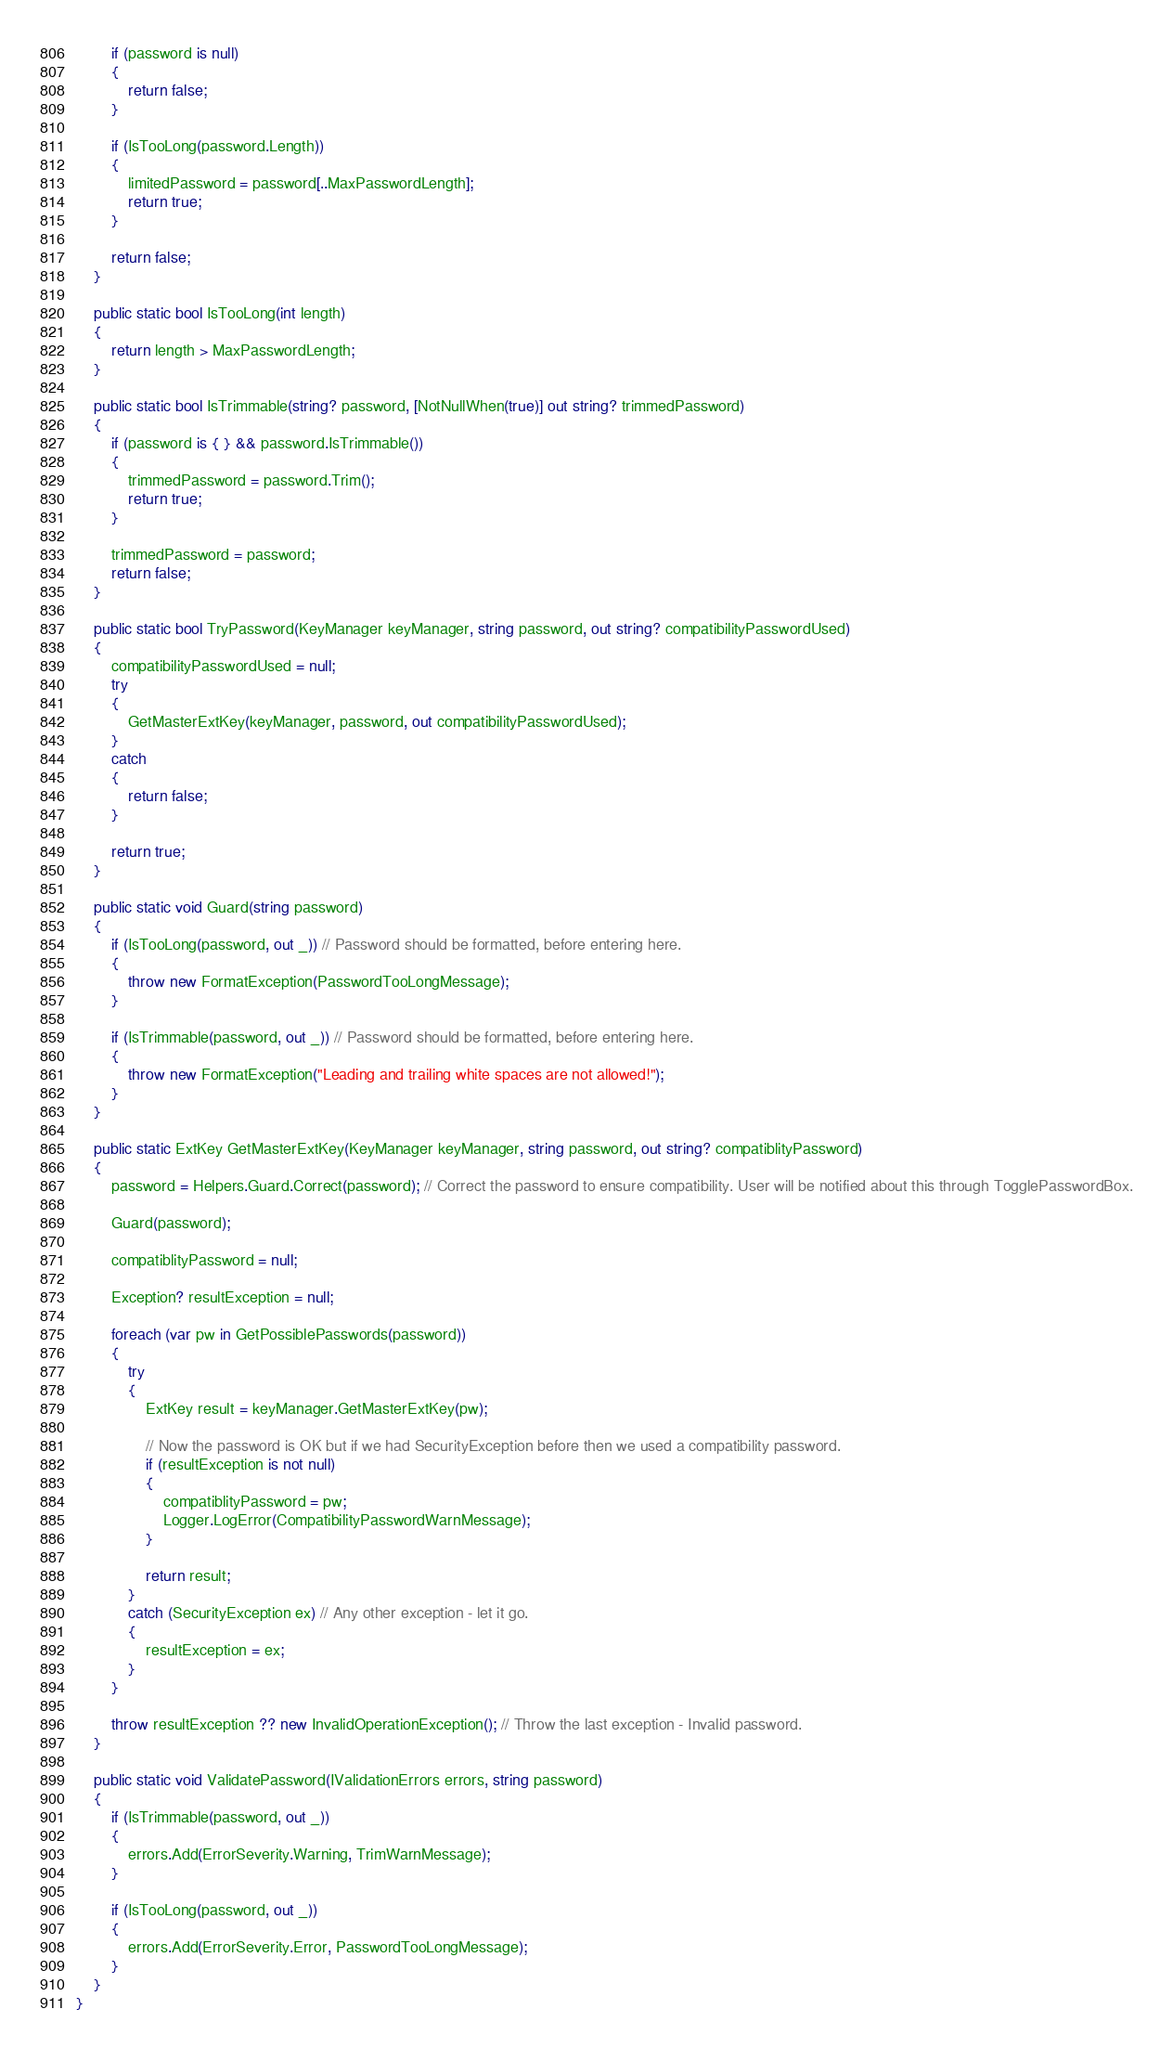<code> <loc_0><loc_0><loc_500><loc_500><_C#_>		if (password is null)
		{
			return false;
		}

		if (IsTooLong(password.Length))
		{
			limitedPassword = password[..MaxPasswordLength];
			return true;
		}

		return false;
	}

	public static bool IsTooLong(int length)
	{
		return length > MaxPasswordLength;
	}

	public static bool IsTrimmable(string? password, [NotNullWhen(true)] out string? trimmedPassword)
	{
		if (password is { } && password.IsTrimmable())
		{
			trimmedPassword = password.Trim();
			return true;
		}

		trimmedPassword = password;
		return false;
	}

	public static bool TryPassword(KeyManager keyManager, string password, out string? compatibilityPasswordUsed)
	{
		compatibilityPasswordUsed = null;
		try
		{
			GetMasterExtKey(keyManager, password, out compatibilityPasswordUsed);
		}
		catch
		{
			return false;
		}

		return true;
	}

	public static void Guard(string password)
	{
		if (IsTooLong(password, out _)) // Password should be formatted, before entering here.
		{
			throw new FormatException(PasswordTooLongMessage);
		}

		if (IsTrimmable(password, out _)) // Password should be formatted, before entering here.
		{
			throw new FormatException("Leading and trailing white spaces are not allowed!");
		}
	}

	public static ExtKey GetMasterExtKey(KeyManager keyManager, string password, out string? compatiblityPassword)
	{
		password = Helpers.Guard.Correct(password); // Correct the password to ensure compatibility. User will be notified about this through TogglePasswordBox.

		Guard(password);

		compatiblityPassword = null;

		Exception? resultException = null;

		foreach (var pw in GetPossiblePasswords(password))
		{
			try
			{
				ExtKey result = keyManager.GetMasterExtKey(pw);

				// Now the password is OK but if we had SecurityException before then we used a compatibility password.
				if (resultException is not null)
				{
					compatiblityPassword = pw;
					Logger.LogError(CompatibilityPasswordWarnMessage);
				}

				return result;
			}
			catch (SecurityException ex) // Any other exception - let it go.
			{
				resultException = ex;
			}
		}

		throw resultException ?? new InvalidOperationException(); // Throw the last exception - Invalid password.
	}

	public static void ValidatePassword(IValidationErrors errors, string password)
	{
		if (IsTrimmable(password, out _))
		{
			errors.Add(ErrorSeverity.Warning, TrimWarnMessage);
		}

		if (IsTooLong(password, out _))
		{
			errors.Add(ErrorSeverity.Error, PasswordTooLongMessage);
		}
	}
}
</code> 